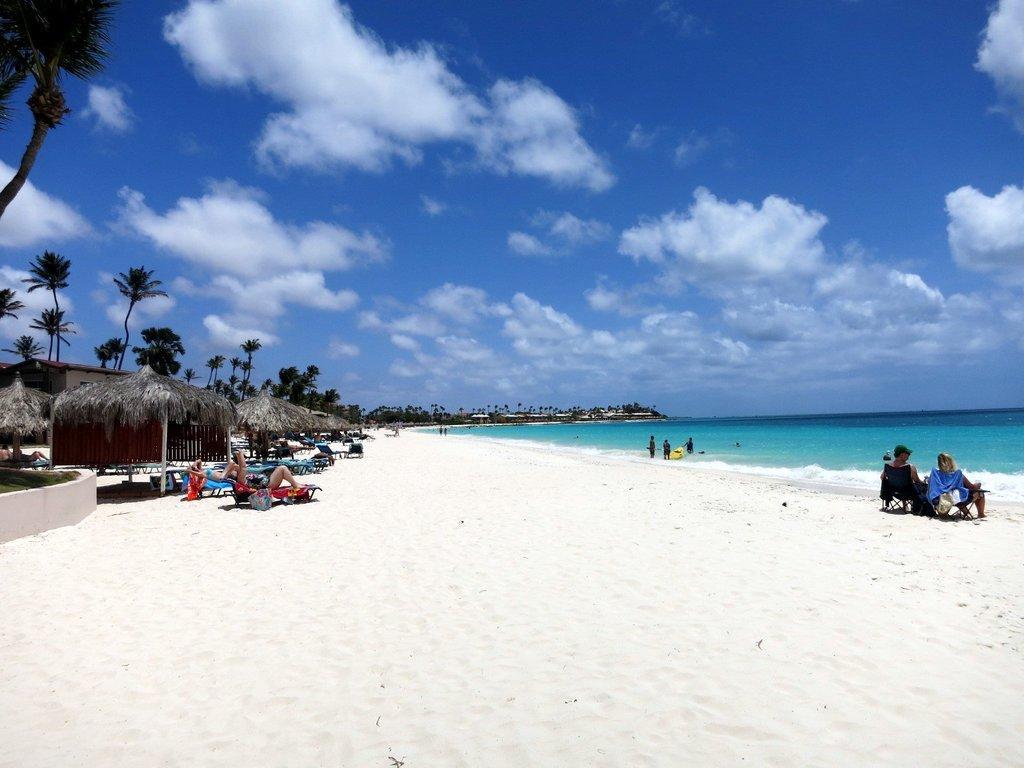How would you summarize this image in a sentence or two? In the picture we can see a beach with sand and some sheds near it, we can see some people are lying on the lying chairs and near the sand, we can see the water, which is blue in color and in the background we can see tall trees and sky with clouds. 